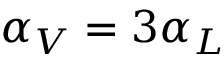<formula> <loc_0><loc_0><loc_500><loc_500>\alpha _ { V } = 3 \alpha _ { L }</formula> 